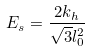Convert formula to latex. <formula><loc_0><loc_0><loc_500><loc_500>E _ { s } = \frac { 2 k _ { h } } { \sqrt { 3 } l _ { 0 } ^ { 2 } }</formula> 